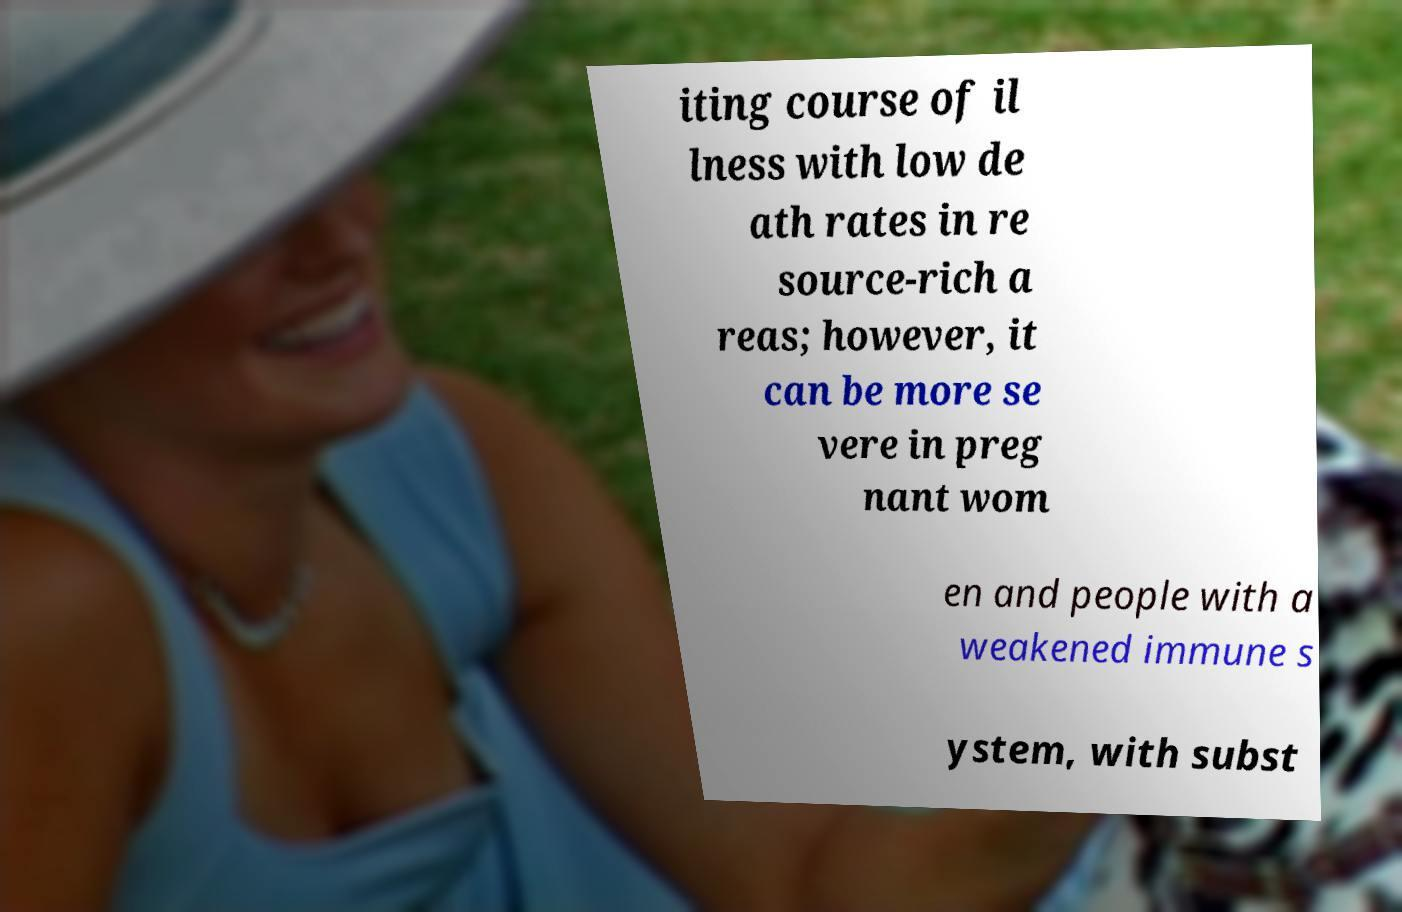Please identify and transcribe the text found in this image. iting course of il lness with low de ath rates in re source-rich a reas; however, it can be more se vere in preg nant wom en and people with a weakened immune s ystem, with subst 